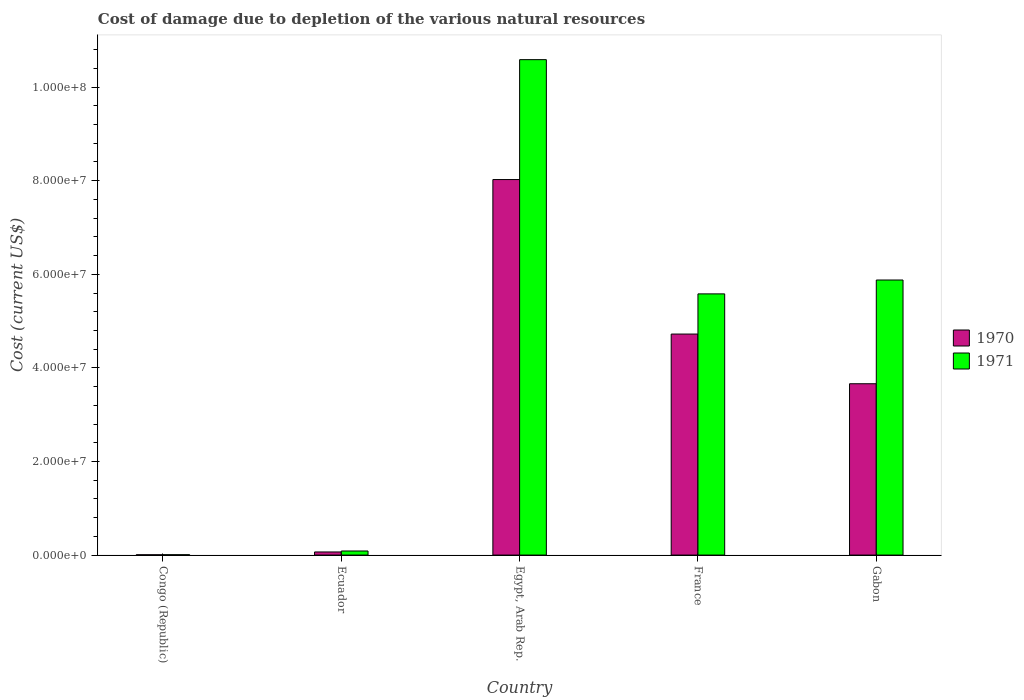How many groups of bars are there?
Offer a terse response. 5. Are the number of bars per tick equal to the number of legend labels?
Make the answer very short. Yes. How many bars are there on the 5th tick from the left?
Give a very brief answer. 2. What is the label of the 3rd group of bars from the left?
Offer a terse response. Egypt, Arab Rep. In how many cases, is the number of bars for a given country not equal to the number of legend labels?
Offer a terse response. 0. What is the cost of damage caused due to the depletion of various natural resources in 1971 in Gabon?
Offer a very short reply. 5.88e+07. Across all countries, what is the maximum cost of damage caused due to the depletion of various natural resources in 1970?
Offer a terse response. 8.02e+07. Across all countries, what is the minimum cost of damage caused due to the depletion of various natural resources in 1970?
Your answer should be very brief. 6.34e+04. In which country was the cost of damage caused due to the depletion of various natural resources in 1971 maximum?
Your answer should be very brief. Egypt, Arab Rep. In which country was the cost of damage caused due to the depletion of various natural resources in 1971 minimum?
Offer a very short reply. Congo (Republic). What is the total cost of damage caused due to the depletion of various natural resources in 1970 in the graph?
Provide a succinct answer. 1.65e+08. What is the difference between the cost of damage caused due to the depletion of various natural resources in 1970 in Ecuador and that in France?
Your answer should be compact. -4.66e+07. What is the difference between the cost of damage caused due to the depletion of various natural resources in 1971 in Ecuador and the cost of damage caused due to the depletion of various natural resources in 1970 in Gabon?
Offer a very short reply. -3.57e+07. What is the average cost of damage caused due to the depletion of various natural resources in 1971 per country?
Your answer should be very brief. 4.43e+07. What is the difference between the cost of damage caused due to the depletion of various natural resources of/in 1970 and cost of damage caused due to the depletion of various natural resources of/in 1971 in Gabon?
Make the answer very short. -2.22e+07. In how many countries, is the cost of damage caused due to the depletion of various natural resources in 1971 greater than 20000000 US$?
Provide a short and direct response. 3. What is the ratio of the cost of damage caused due to the depletion of various natural resources in 1971 in Congo (Republic) to that in Ecuador?
Ensure brevity in your answer.  0.08. Is the cost of damage caused due to the depletion of various natural resources in 1970 in Congo (Republic) less than that in Ecuador?
Ensure brevity in your answer.  Yes. Is the difference between the cost of damage caused due to the depletion of various natural resources in 1970 in Egypt, Arab Rep. and Gabon greater than the difference between the cost of damage caused due to the depletion of various natural resources in 1971 in Egypt, Arab Rep. and Gabon?
Provide a short and direct response. No. What is the difference between the highest and the second highest cost of damage caused due to the depletion of various natural resources in 1971?
Ensure brevity in your answer.  -4.71e+07. What is the difference between the highest and the lowest cost of damage caused due to the depletion of various natural resources in 1971?
Keep it short and to the point. 1.06e+08. Is the sum of the cost of damage caused due to the depletion of various natural resources in 1970 in Congo (Republic) and France greater than the maximum cost of damage caused due to the depletion of various natural resources in 1971 across all countries?
Provide a short and direct response. No. What does the 1st bar from the left in Egypt, Arab Rep. represents?
Offer a very short reply. 1970. How many bars are there?
Provide a short and direct response. 10. Are all the bars in the graph horizontal?
Ensure brevity in your answer.  No. How many countries are there in the graph?
Provide a succinct answer. 5. What is the difference between two consecutive major ticks on the Y-axis?
Give a very brief answer. 2.00e+07. Does the graph contain grids?
Make the answer very short. No. Where does the legend appear in the graph?
Ensure brevity in your answer.  Center right. How many legend labels are there?
Keep it short and to the point. 2. How are the legend labels stacked?
Your answer should be very brief. Vertical. What is the title of the graph?
Provide a succinct answer. Cost of damage due to depletion of the various natural resources. What is the label or title of the Y-axis?
Your answer should be compact. Cost (current US$). What is the Cost (current US$) in 1970 in Congo (Republic)?
Your answer should be compact. 6.34e+04. What is the Cost (current US$) of 1971 in Congo (Republic)?
Your answer should be compact. 7.34e+04. What is the Cost (current US$) in 1970 in Ecuador?
Keep it short and to the point. 6.65e+05. What is the Cost (current US$) in 1971 in Ecuador?
Your response must be concise. 8.71e+05. What is the Cost (current US$) in 1970 in Egypt, Arab Rep.?
Provide a short and direct response. 8.02e+07. What is the Cost (current US$) in 1971 in Egypt, Arab Rep.?
Your answer should be compact. 1.06e+08. What is the Cost (current US$) in 1970 in France?
Give a very brief answer. 4.72e+07. What is the Cost (current US$) of 1971 in France?
Keep it short and to the point. 5.58e+07. What is the Cost (current US$) in 1970 in Gabon?
Ensure brevity in your answer.  3.66e+07. What is the Cost (current US$) of 1971 in Gabon?
Offer a terse response. 5.88e+07. Across all countries, what is the maximum Cost (current US$) in 1970?
Your answer should be very brief. 8.02e+07. Across all countries, what is the maximum Cost (current US$) of 1971?
Offer a very short reply. 1.06e+08. Across all countries, what is the minimum Cost (current US$) of 1970?
Make the answer very short. 6.34e+04. Across all countries, what is the minimum Cost (current US$) in 1971?
Give a very brief answer. 7.34e+04. What is the total Cost (current US$) of 1970 in the graph?
Your answer should be very brief. 1.65e+08. What is the total Cost (current US$) in 1971 in the graph?
Offer a terse response. 2.21e+08. What is the difference between the Cost (current US$) in 1970 in Congo (Republic) and that in Ecuador?
Ensure brevity in your answer.  -6.01e+05. What is the difference between the Cost (current US$) of 1971 in Congo (Republic) and that in Ecuador?
Your answer should be very brief. -7.98e+05. What is the difference between the Cost (current US$) of 1970 in Congo (Republic) and that in Egypt, Arab Rep.?
Your answer should be very brief. -8.02e+07. What is the difference between the Cost (current US$) of 1971 in Congo (Republic) and that in Egypt, Arab Rep.?
Provide a succinct answer. -1.06e+08. What is the difference between the Cost (current US$) of 1970 in Congo (Republic) and that in France?
Your answer should be very brief. -4.72e+07. What is the difference between the Cost (current US$) in 1971 in Congo (Republic) and that in France?
Keep it short and to the point. -5.57e+07. What is the difference between the Cost (current US$) of 1970 in Congo (Republic) and that in Gabon?
Ensure brevity in your answer.  -3.65e+07. What is the difference between the Cost (current US$) in 1971 in Congo (Republic) and that in Gabon?
Offer a very short reply. -5.87e+07. What is the difference between the Cost (current US$) of 1970 in Ecuador and that in Egypt, Arab Rep.?
Your answer should be very brief. -7.96e+07. What is the difference between the Cost (current US$) of 1971 in Ecuador and that in Egypt, Arab Rep.?
Keep it short and to the point. -1.05e+08. What is the difference between the Cost (current US$) of 1970 in Ecuador and that in France?
Keep it short and to the point. -4.66e+07. What is the difference between the Cost (current US$) of 1971 in Ecuador and that in France?
Offer a very short reply. -5.49e+07. What is the difference between the Cost (current US$) in 1970 in Ecuador and that in Gabon?
Your answer should be compact. -3.59e+07. What is the difference between the Cost (current US$) in 1971 in Ecuador and that in Gabon?
Offer a terse response. -5.79e+07. What is the difference between the Cost (current US$) in 1970 in Egypt, Arab Rep. and that in France?
Offer a terse response. 3.30e+07. What is the difference between the Cost (current US$) of 1971 in Egypt, Arab Rep. and that in France?
Keep it short and to the point. 5.01e+07. What is the difference between the Cost (current US$) in 1970 in Egypt, Arab Rep. and that in Gabon?
Your response must be concise. 4.36e+07. What is the difference between the Cost (current US$) in 1971 in Egypt, Arab Rep. and that in Gabon?
Offer a very short reply. 4.71e+07. What is the difference between the Cost (current US$) in 1970 in France and that in Gabon?
Your response must be concise. 1.06e+07. What is the difference between the Cost (current US$) of 1971 in France and that in Gabon?
Make the answer very short. -2.96e+06. What is the difference between the Cost (current US$) of 1970 in Congo (Republic) and the Cost (current US$) of 1971 in Ecuador?
Your response must be concise. -8.08e+05. What is the difference between the Cost (current US$) in 1970 in Congo (Republic) and the Cost (current US$) in 1971 in Egypt, Arab Rep.?
Your response must be concise. -1.06e+08. What is the difference between the Cost (current US$) in 1970 in Congo (Republic) and the Cost (current US$) in 1971 in France?
Make the answer very short. -5.58e+07. What is the difference between the Cost (current US$) in 1970 in Congo (Republic) and the Cost (current US$) in 1971 in Gabon?
Make the answer very short. -5.87e+07. What is the difference between the Cost (current US$) in 1970 in Ecuador and the Cost (current US$) in 1971 in Egypt, Arab Rep.?
Make the answer very short. -1.05e+08. What is the difference between the Cost (current US$) in 1970 in Ecuador and the Cost (current US$) in 1971 in France?
Provide a short and direct response. -5.52e+07. What is the difference between the Cost (current US$) in 1970 in Ecuador and the Cost (current US$) in 1971 in Gabon?
Keep it short and to the point. -5.81e+07. What is the difference between the Cost (current US$) of 1970 in Egypt, Arab Rep. and the Cost (current US$) of 1971 in France?
Ensure brevity in your answer.  2.44e+07. What is the difference between the Cost (current US$) in 1970 in Egypt, Arab Rep. and the Cost (current US$) in 1971 in Gabon?
Give a very brief answer. 2.15e+07. What is the difference between the Cost (current US$) of 1970 in France and the Cost (current US$) of 1971 in Gabon?
Your answer should be very brief. -1.15e+07. What is the average Cost (current US$) in 1970 per country?
Your response must be concise. 3.30e+07. What is the average Cost (current US$) in 1971 per country?
Give a very brief answer. 4.43e+07. What is the difference between the Cost (current US$) of 1970 and Cost (current US$) of 1971 in Congo (Republic)?
Keep it short and to the point. -1.00e+04. What is the difference between the Cost (current US$) in 1970 and Cost (current US$) in 1971 in Ecuador?
Offer a terse response. -2.07e+05. What is the difference between the Cost (current US$) in 1970 and Cost (current US$) in 1971 in Egypt, Arab Rep.?
Your answer should be very brief. -2.56e+07. What is the difference between the Cost (current US$) of 1970 and Cost (current US$) of 1971 in France?
Ensure brevity in your answer.  -8.59e+06. What is the difference between the Cost (current US$) in 1970 and Cost (current US$) in 1971 in Gabon?
Keep it short and to the point. -2.22e+07. What is the ratio of the Cost (current US$) in 1970 in Congo (Republic) to that in Ecuador?
Your answer should be compact. 0.1. What is the ratio of the Cost (current US$) in 1971 in Congo (Republic) to that in Ecuador?
Your response must be concise. 0.08. What is the ratio of the Cost (current US$) of 1970 in Congo (Republic) to that in Egypt, Arab Rep.?
Your answer should be very brief. 0. What is the ratio of the Cost (current US$) in 1971 in Congo (Republic) to that in Egypt, Arab Rep.?
Keep it short and to the point. 0. What is the ratio of the Cost (current US$) of 1970 in Congo (Republic) to that in France?
Your answer should be very brief. 0. What is the ratio of the Cost (current US$) of 1971 in Congo (Republic) to that in France?
Your answer should be very brief. 0. What is the ratio of the Cost (current US$) in 1970 in Congo (Republic) to that in Gabon?
Ensure brevity in your answer.  0. What is the ratio of the Cost (current US$) in 1971 in Congo (Republic) to that in Gabon?
Make the answer very short. 0. What is the ratio of the Cost (current US$) in 1970 in Ecuador to that in Egypt, Arab Rep.?
Make the answer very short. 0.01. What is the ratio of the Cost (current US$) of 1971 in Ecuador to that in Egypt, Arab Rep.?
Offer a terse response. 0.01. What is the ratio of the Cost (current US$) in 1970 in Ecuador to that in France?
Ensure brevity in your answer.  0.01. What is the ratio of the Cost (current US$) in 1971 in Ecuador to that in France?
Your answer should be very brief. 0.02. What is the ratio of the Cost (current US$) in 1970 in Ecuador to that in Gabon?
Provide a succinct answer. 0.02. What is the ratio of the Cost (current US$) of 1971 in Ecuador to that in Gabon?
Offer a very short reply. 0.01. What is the ratio of the Cost (current US$) in 1970 in Egypt, Arab Rep. to that in France?
Keep it short and to the point. 1.7. What is the ratio of the Cost (current US$) in 1971 in Egypt, Arab Rep. to that in France?
Make the answer very short. 1.9. What is the ratio of the Cost (current US$) in 1970 in Egypt, Arab Rep. to that in Gabon?
Provide a succinct answer. 2.19. What is the ratio of the Cost (current US$) in 1971 in Egypt, Arab Rep. to that in Gabon?
Your answer should be compact. 1.8. What is the ratio of the Cost (current US$) of 1970 in France to that in Gabon?
Offer a very short reply. 1.29. What is the ratio of the Cost (current US$) of 1971 in France to that in Gabon?
Your answer should be very brief. 0.95. What is the difference between the highest and the second highest Cost (current US$) in 1970?
Your answer should be compact. 3.30e+07. What is the difference between the highest and the second highest Cost (current US$) in 1971?
Your answer should be compact. 4.71e+07. What is the difference between the highest and the lowest Cost (current US$) in 1970?
Your response must be concise. 8.02e+07. What is the difference between the highest and the lowest Cost (current US$) of 1971?
Give a very brief answer. 1.06e+08. 